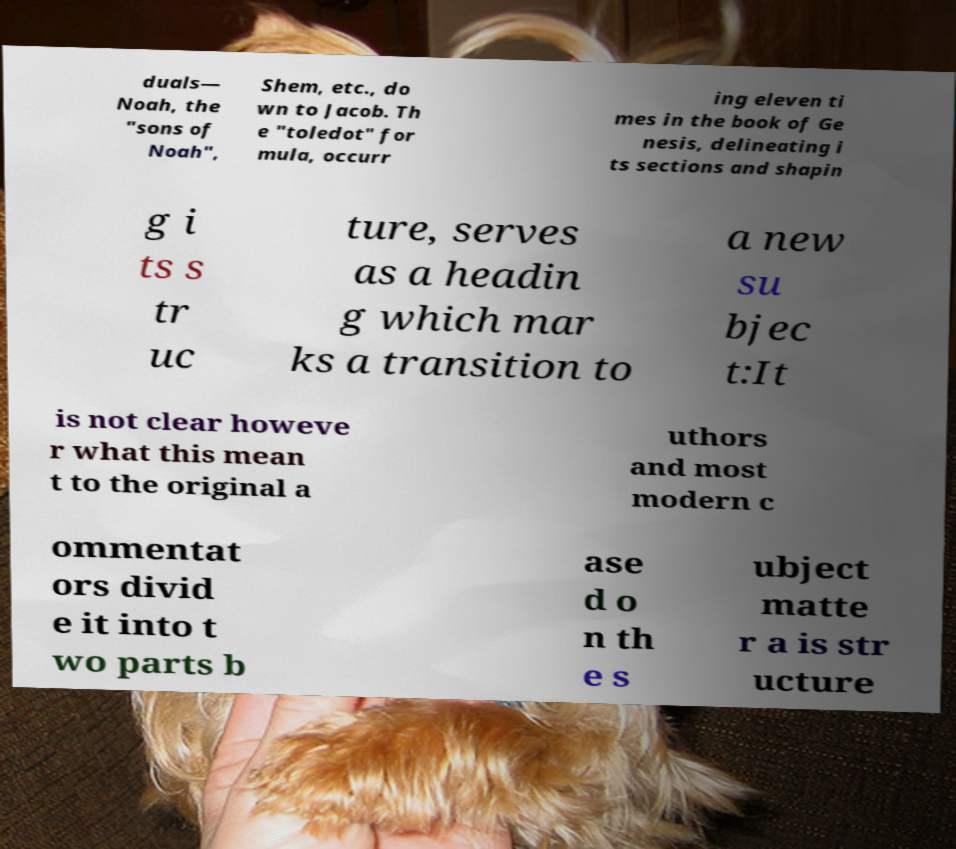Can you accurately transcribe the text from the provided image for me? duals— Noah, the "sons of Noah", Shem, etc., do wn to Jacob. Th e "toledot" for mula, occurr ing eleven ti mes in the book of Ge nesis, delineating i ts sections and shapin g i ts s tr uc ture, serves as a headin g which mar ks a transition to a new su bjec t:It is not clear howeve r what this mean t to the original a uthors and most modern c ommentat ors divid e it into t wo parts b ase d o n th e s ubject matte r a is str ucture 